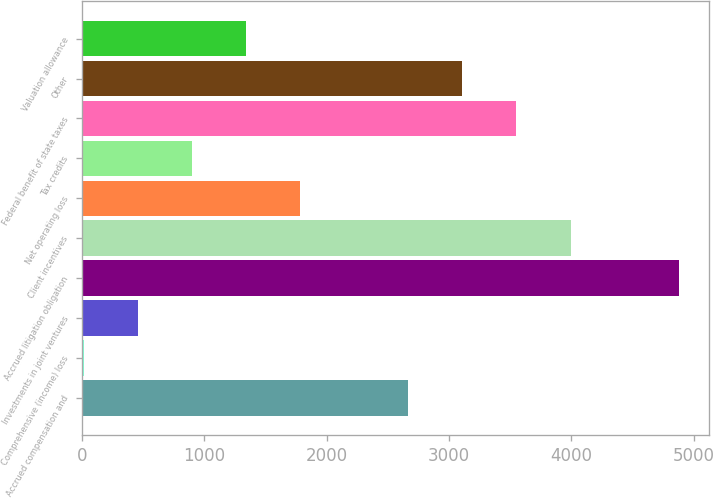Convert chart. <chart><loc_0><loc_0><loc_500><loc_500><bar_chart><fcel>Accrued compensation and<fcel>Comprehensive (income) loss<fcel>Investments in joint ventures<fcel>Accrued litigation obligation<fcel>Client incentives<fcel>Net operating loss<fcel>Tax credits<fcel>Federal benefit of state taxes<fcel>Other<fcel>Valuation allowance<nl><fcel>2666.6<fcel>14<fcel>456.1<fcel>4877.1<fcel>3992.9<fcel>1782.4<fcel>898.2<fcel>3550.8<fcel>3108.7<fcel>1340.3<nl></chart> 